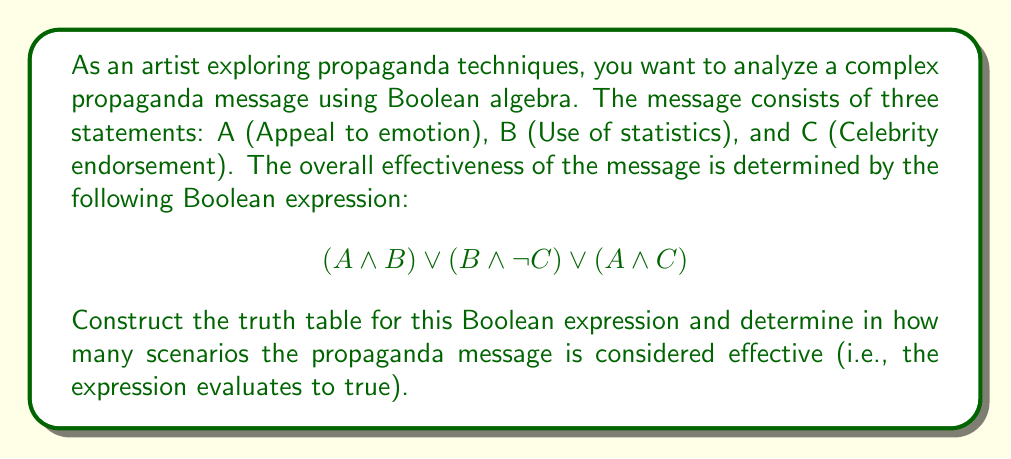Give your solution to this math problem. To solve this problem, we need to follow these steps:

1. Identify the variables: A, B, and C
2. Create a truth table with 8 rows (2^3 combinations)
3. Evaluate each part of the expression:
   a. $(A \land B)$
   b. $(B \land \neg C)$
   c. $(A \land C)$
4. Combine the results using OR operations
5. Count the number of true outcomes

Let's construct the truth table:

$$
\begin{array}{|c|c|c|c|c|c|c|c|}
\hline
A & B & C & \neg C & (A \land B) & (B \land \neg C) & (A \land C) & \text{Result} \\
\hline
0 & 0 & 0 & 1 & 0 & 0 & 0 & 0 \\
0 & 0 & 1 & 0 & 0 & 0 & 0 & 0 \\
0 & 1 & 0 & 1 & 0 & 1 & 0 & 1 \\
0 & 1 & 1 & 0 & 0 & 0 & 0 & 0 \\
1 & 0 & 0 & 1 & 0 & 0 & 0 & 0 \\
1 & 0 & 1 & 0 & 0 & 0 & 1 & 1 \\
1 & 1 & 0 & 1 & 1 & 1 & 0 & 1 \\
1 & 1 & 1 & 0 & 1 & 0 & 1 & 1 \\
\hline
\end{array}
$$

Now, we count the number of true outcomes in the Result column. There are 4 rows where the expression evaluates to true.
Answer: 4 scenarios 